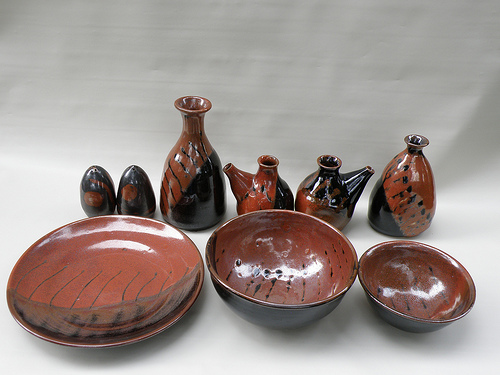Please provide a short description for this region: [0.0, 0.55, 0.4, 0.82]. The region with coordinates [0.0, 0.55, 0.4, 0.82] contains a red plate with black streaks on the glaze. This plate's unique design makes it a standout piece. 